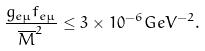<formula> <loc_0><loc_0><loc_500><loc_500>\frac { g _ { e \mu } f _ { e \mu } } { \overline { M } ^ { 2 } } \leq 3 \times 1 0 ^ { - 6 } G e V ^ { - 2 } .</formula> 